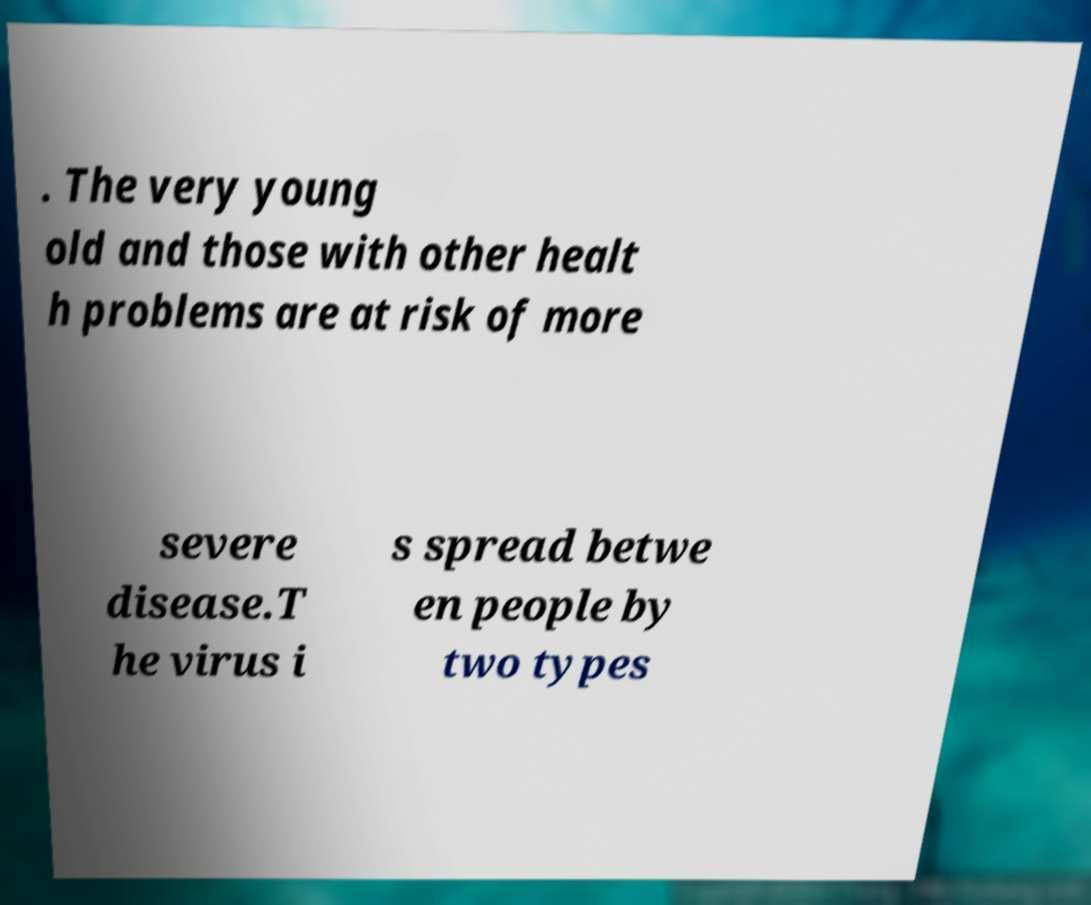Could you assist in decoding the text presented in this image and type it out clearly? . The very young old and those with other healt h problems are at risk of more severe disease.T he virus i s spread betwe en people by two types 